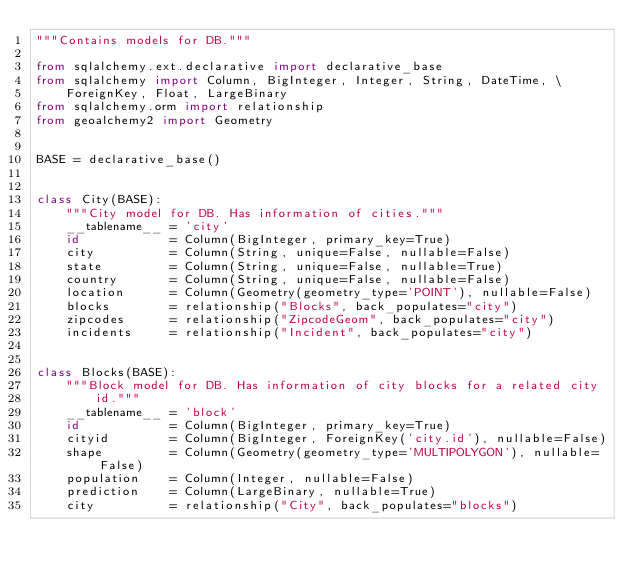Convert code to text. <code><loc_0><loc_0><loc_500><loc_500><_Python_>"""Contains models for DB."""

from sqlalchemy.ext.declarative import declarative_base
from sqlalchemy import Column, BigInteger, Integer, String, DateTime, \
    ForeignKey, Float, LargeBinary
from sqlalchemy.orm import relationship
from geoalchemy2 import Geometry


BASE = declarative_base()


class City(BASE):
    """City model for DB. Has information of cities."""
    __tablename__ = 'city'
    id            = Column(BigInteger, primary_key=True)
    city          = Column(String, unique=False, nullable=False)
    state         = Column(String, unique=False, nullable=True)
    country       = Column(String, unique=False, nullable=False)
    location      = Column(Geometry(geometry_type='POINT'), nullable=False)
    blocks        = relationship("Blocks", back_populates="city")
    zipcodes      = relationship("ZipcodeGeom", back_populates="city")
    incidents     = relationship("Incident", back_populates="city")


class Blocks(BASE):
    """Block model for DB. Has information of city blocks for a related city
        id."""
    __tablename__ = 'block'
    id            = Column(BigInteger, primary_key=True)
    cityid        = Column(BigInteger, ForeignKey('city.id'), nullable=False)
    shape         = Column(Geometry(geometry_type='MULTIPOLYGON'), nullable=False)
    population    = Column(Integer, nullable=False)
    prediction    = Column(LargeBinary, nullable=True)
    city          = relationship("City", back_populates="blocks")</code> 